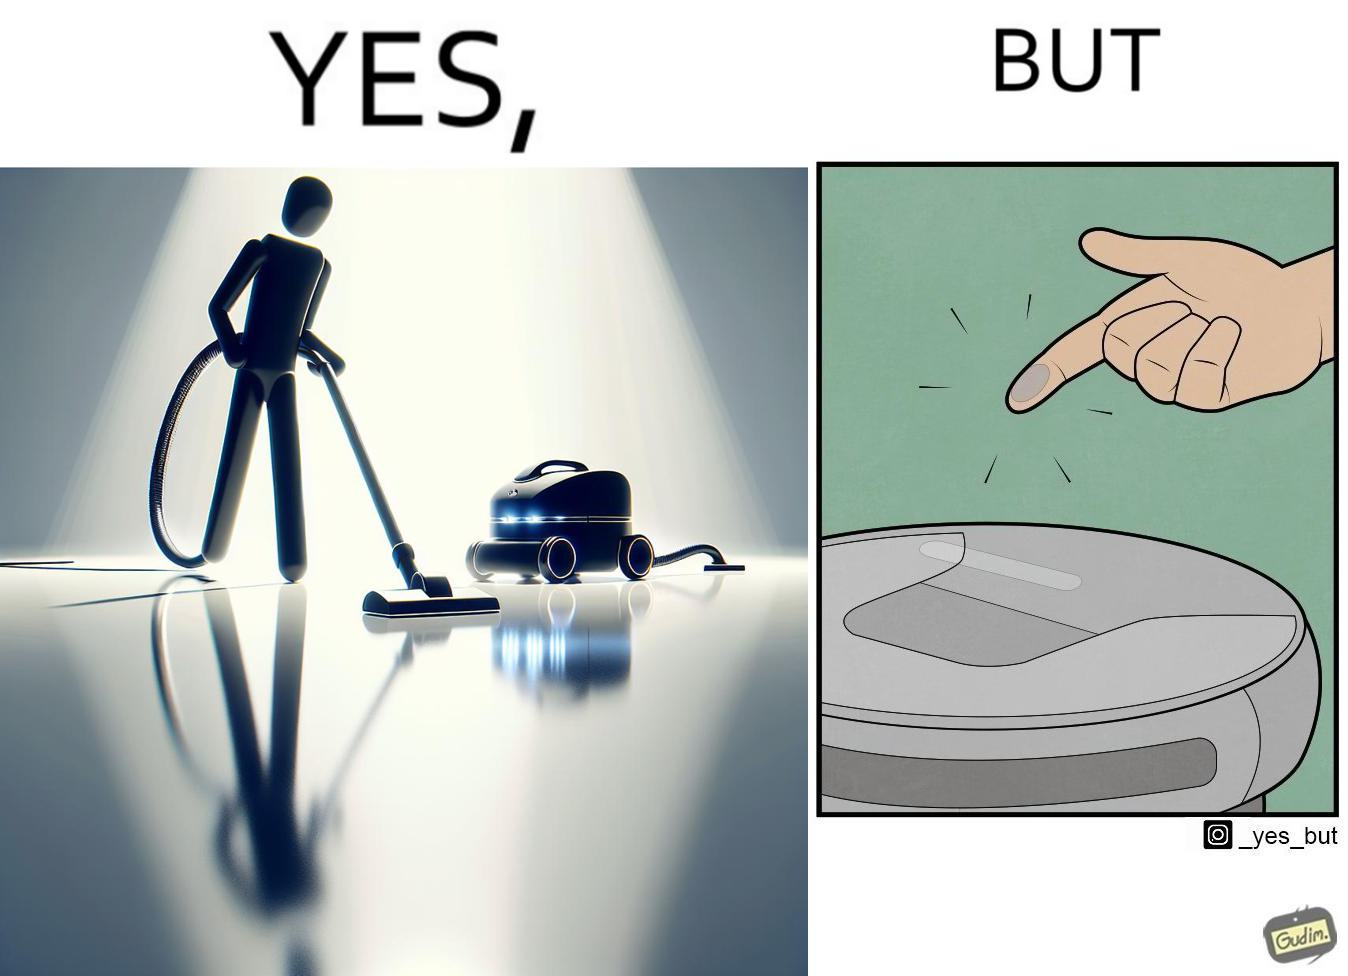What is the satirical meaning behind this image? This is funny, because the machine while doing its job cleans everything but ends up being dirty itself. 